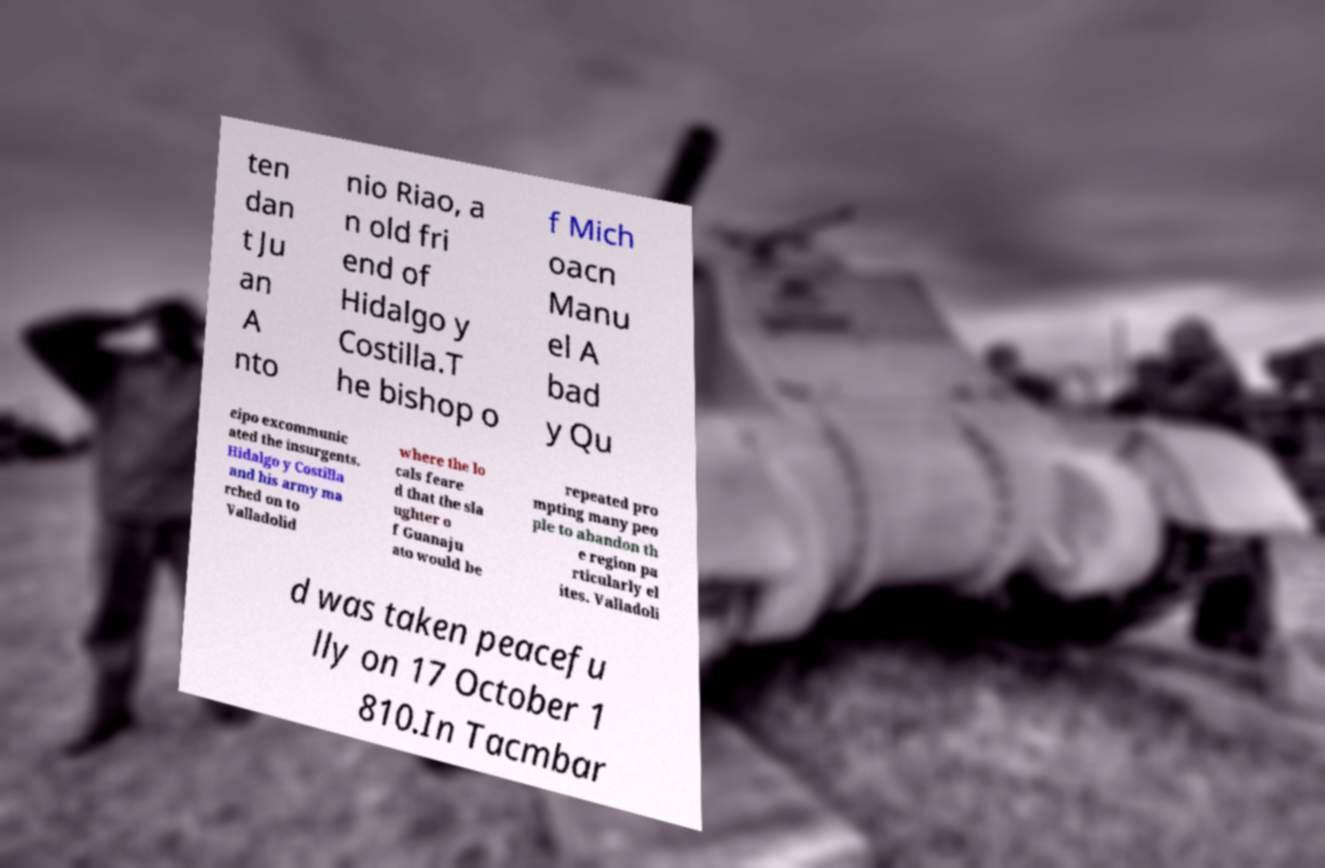What messages or text are displayed in this image? I need them in a readable, typed format. ten dan t Ju an A nto nio Riao, a n old fri end of Hidalgo y Costilla.T he bishop o f Mich oacn Manu el A bad y Qu eipo excommunic ated the insurgents. Hidalgo y Costilla and his army ma rched on to Valladolid where the lo cals feare d that the sla ughter o f Guanaju ato would be repeated pro mpting many peo ple to abandon th e region pa rticularly el ites. Valladoli d was taken peacefu lly on 17 October 1 810.In Tacmbar 